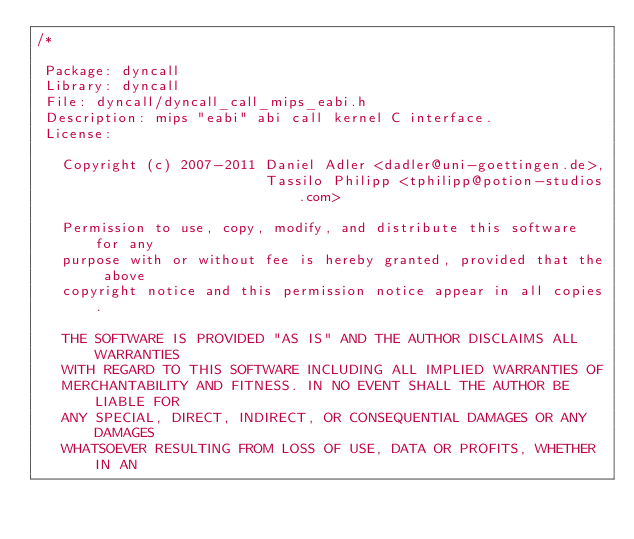Convert code to text. <code><loc_0><loc_0><loc_500><loc_500><_C_>/*

 Package: dyncall
 Library: dyncall
 File: dyncall/dyncall_call_mips_eabi.h
 Description: mips "eabi" abi call kernel C interface.
 License:

   Copyright (c) 2007-2011 Daniel Adler <dadler@uni-goettingen.de>, 
                           Tassilo Philipp <tphilipp@potion-studios.com>

   Permission to use, copy, modify, and distribute this software for any
   purpose with or without fee is hereby granted, provided that the above
   copyright notice and this permission notice appear in all copies.

   THE SOFTWARE IS PROVIDED "AS IS" AND THE AUTHOR DISCLAIMS ALL WARRANTIES
   WITH REGARD TO THIS SOFTWARE INCLUDING ALL IMPLIED WARRANTIES OF
   MERCHANTABILITY AND FITNESS. IN NO EVENT SHALL THE AUTHOR BE LIABLE FOR
   ANY SPECIAL, DIRECT, INDIRECT, OR CONSEQUENTIAL DAMAGES OR ANY DAMAGES
   WHATSOEVER RESULTING FROM LOSS OF USE, DATA OR PROFITS, WHETHER IN AN</code> 